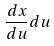<formula> <loc_0><loc_0><loc_500><loc_500>\frac { d x } { d u } d u</formula> 